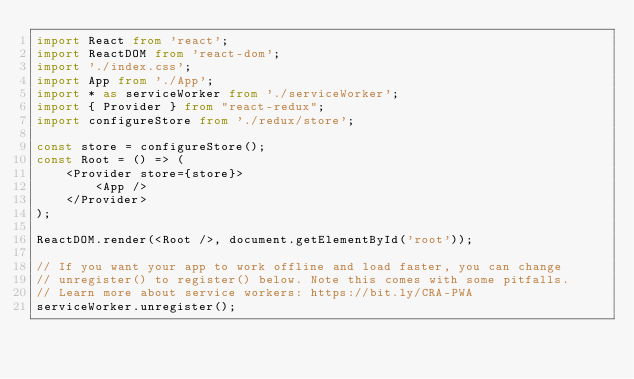Convert code to text. <code><loc_0><loc_0><loc_500><loc_500><_TypeScript_>import React from 'react';
import ReactDOM from 'react-dom';
import './index.css';
import App from './App';
import * as serviceWorker from './serviceWorker';
import { Provider } from "react-redux";
import configureStore from './redux/store';

const store = configureStore();
const Root = () => (
    <Provider store={store}>
        <App />
    </Provider>
);

ReactDOM.render(<Root />, document.getElementById('root'));

// If you want your app to work offline and load faster, you can change
// unregister() to register() below. Note this comes with some pitfalls.
// Learn more about service workers: https://bit.ly/CRA-PWA
serviceWorker.unregister();
</code> 